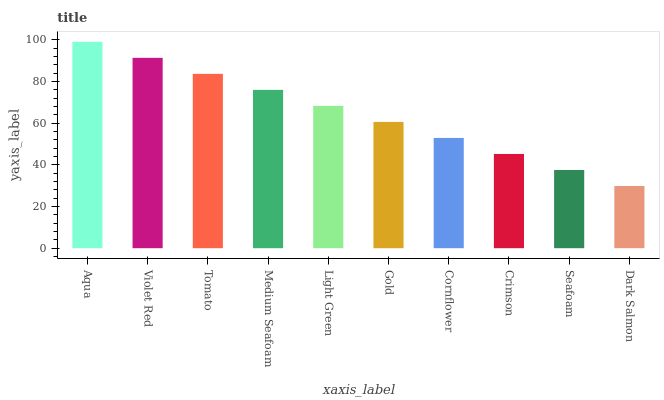Is Dark Salmon the minimum?
Answer yes or no. Yes. Is Aqua the maximum?
Answer yes or no. Yes. Is Violet Red the minimum?
Answer yes or no. No. Is Violet Red the maximum?
Answer yes or no. No. Is Aqua greater than Violet Red?
Answer yes or no. Yes. Is Violet Red less than Aqua?
Answer yes or no. Yes. Is Violet Red greater than Aqua?
Answer yes or no. No. Is Aqua less than Violet Red?
Answer yes or no. No. Is Light Green the high median?
Answer yes or no. Yes. Is Gold the low median?
Answer yes or no. Yes. Is Aqua the high median?
Answer yes or no. No. Is Cornflower the low median?
Answer yes or no. No. 